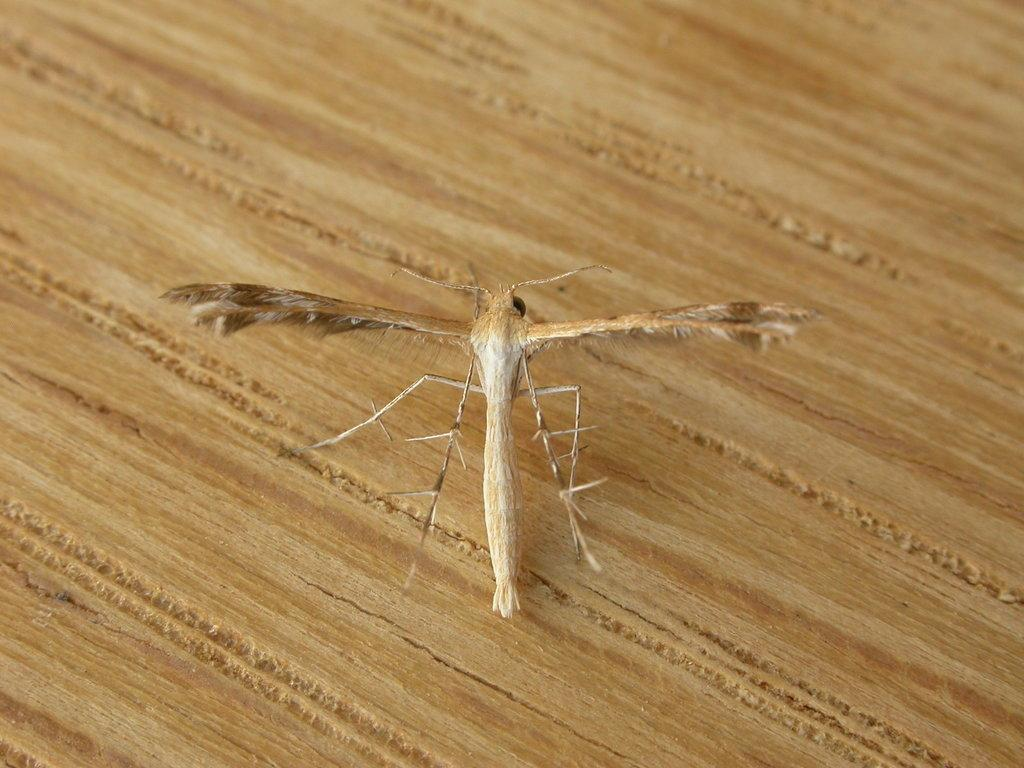What type of creature is present in the image? There is a moth or insect in the image. Where is the moth or insect located? The moth or insect is standing on a table. What reason does the moth or insect give for standing on the table in the image? The image does not provide any information about the moth or insect's reason for standing on the table, so we cannot determine its reason. 